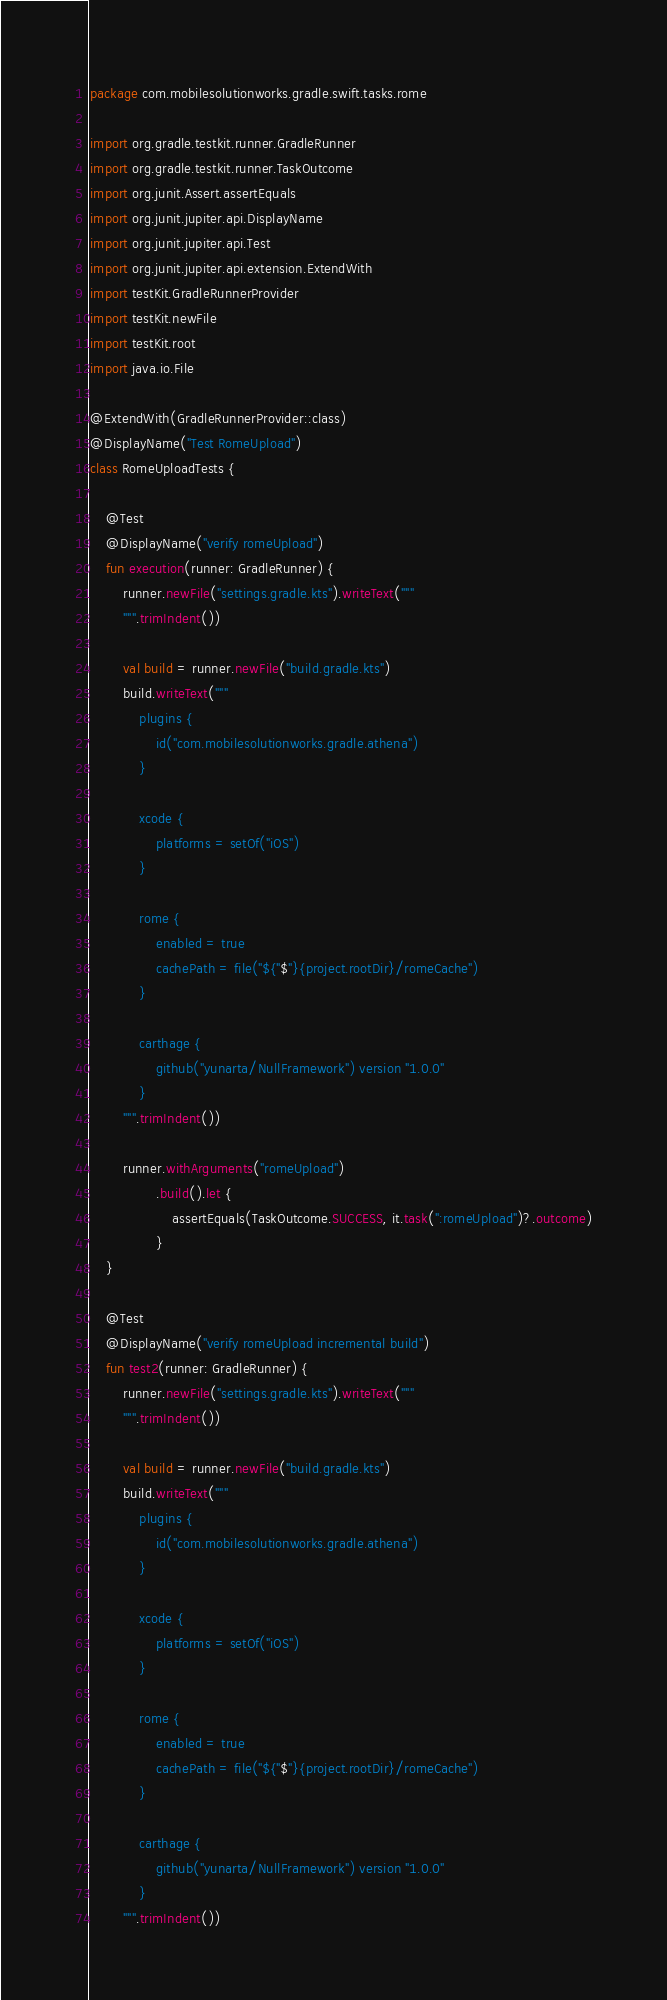Convert code to text. <code><loc_0><loc_0><loc_500><loc_500><_Kotlin_>package com.mobilesolutionworks.gradle.swift.tasks.rome

import org.gradle.testkit.runner.GradleRunner
import org.gradle.testkit.runner.TaskOutcome
import org.junit.Assert.assertEquals
import org.junit.jupiter.api.DisplayName
import org.junit.jupiter.api.Test
import org.junit.jupiter.api.extension.ExtendWith
import testKit.GradleRunnerProvider
import testKit.newFile
import testKit.root
import java.io.File

@ExtendWith(GradleRunnerProvider::class)
@DisplayName("Test RomeUpload")
class RomeUploadTests {

    @Test
    @DisplayName("verify romeUpload")
    fun execution(runner: GradleRunner) {
        runner.newFile("settings.gradle.kts").writeText("""
        """.trimIndent())

        val build = runner.newFile("build.gradle.kts")
        build.writeText("""
            plugins {
                id("com.mobilesolutionworks.gradle.athena")
            }

            xcode {
                platforms = setOf("iOS")
            }

            rome {
                enabled = true
                cachePath = file("${"$"}{project.rootDir}/romeCache")
            }

            carthage {
                github("yunarta/NullFramework") version "1.0.0"
            }
        """.trimIndent())

        runner.withArguments("romeUpload")
                .build().let {
                    assertEquals(TaskOutcome.SUCCESS, it.task(":romeUpload")?.outcome)
                }
    }

    @Test
    @DisplayName("verify romeUpload incremental build")
    fun test2(runner: GradleRunner) {
        runner.newFile("settings.gradle.kts").writeText("""
        """.trimIndent())

        val build = runner.newFile("build.gradle.kts")
        build.writeText("""
            plugins {
                id("com.mobilesolutionworks.gradle.athena")
            }

            xcode {
                platforms = setOf("iOS")
            }

            rome {
                enabled = true
                cachePath = file("${"$"}{project.rootDir}/romeCache")
            }

            carthage {
                github("yunarta/NullFramework") version "1.0.0"
            }
        """.trimIndent())
</code> 